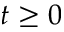<formula> <loc_0><loc_0><loc_500><loc_500>t \geq 0</formula> 